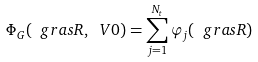Convert formula to latex. <formula><loc_0><loc_0><loc_500><loc_500>\Phi _ { G } ( \ g r a s R , \ V { 0 } ) = \sum _ { j = 1 } ^ { N _ { t } } \varphi _ { j } ( \ g r a s R )</formula> 